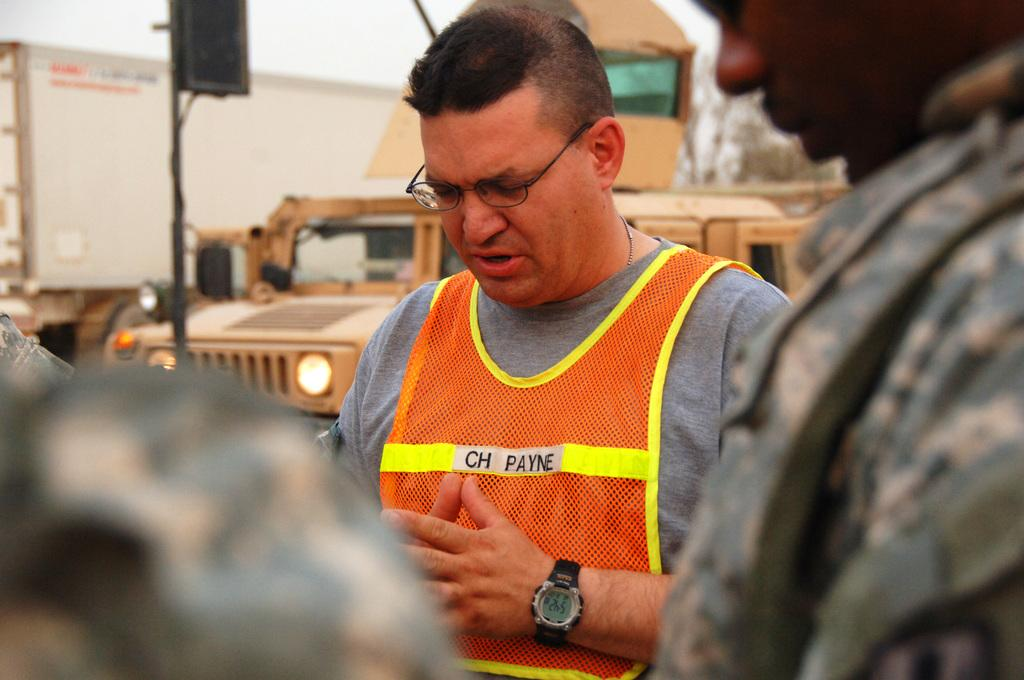Who or what can be seen in the image? There are people in the image. What is located near a pole in the background? There is a black color object near a pole in the background. What else can be seen in the background of the image? There are vehicles and trees in the background. What is visible in the sky in the image? The sky is visible in the background of the image. Can you tell me how many quills are being used by the people in the image? There is no mention of quills in the image, so it is not possible to determine how many are being used. 